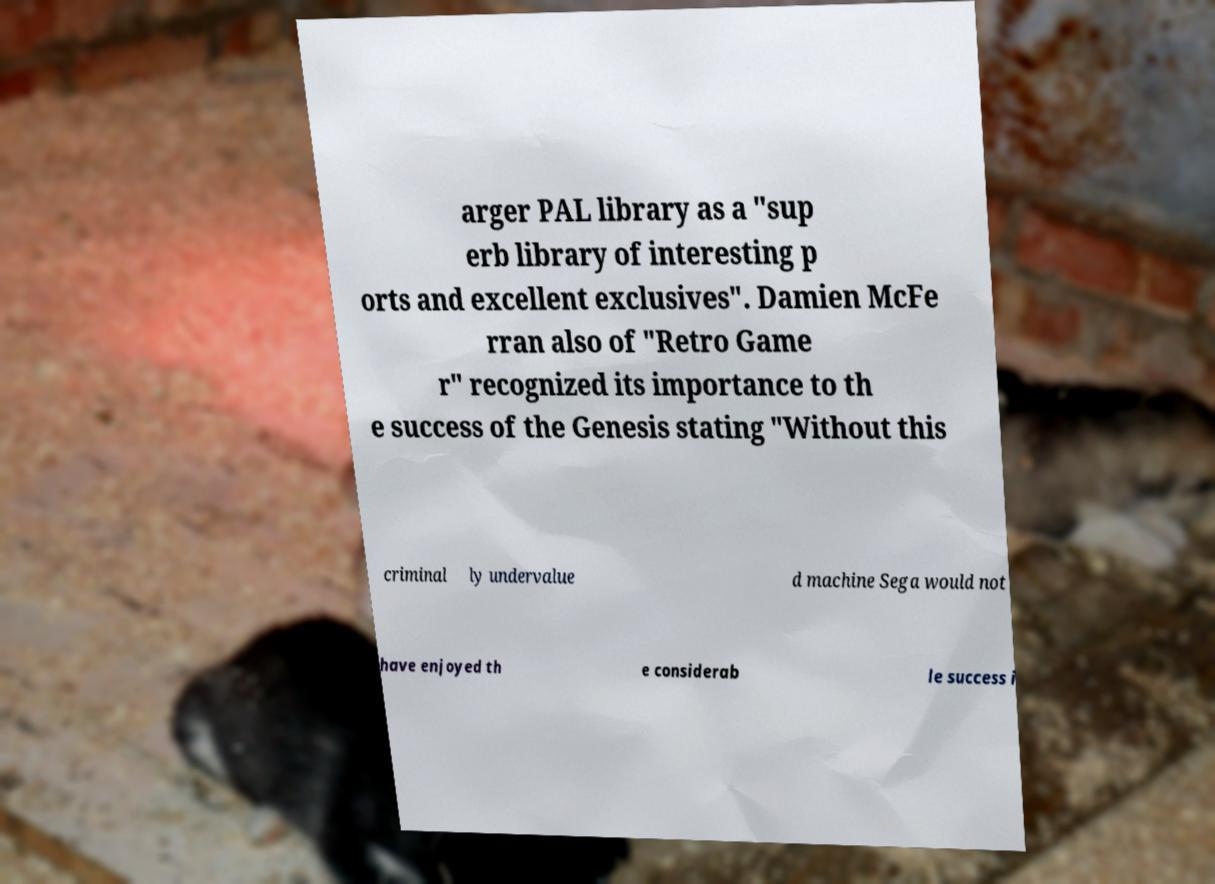Could you extract and type out the text from this image? arger PAL library as a "sup erb library of interesting p orts and excellent exclusives". Damien McFe rran also of "Retro Game r" recognized its importance to th e success of the Genesis stating "Without this criminal ly undervalue d machine Sega would not have enjoyed th e considerab le success i 